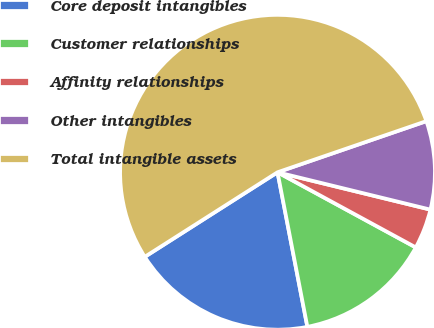<chart> <loc_0><loc_0><loc_500><loc_500><pie_chart><fcel>Core deposit intangibles<fcel>Customer relationships<fcel>Affinity relationships<fcel>Other intangibles<fcel>Total intangible assets<nl><fcel>19.01%<fcel>14.04%<fcel>4.11%<fcel>9.08%<fcel>53.76%<nl></chart> 